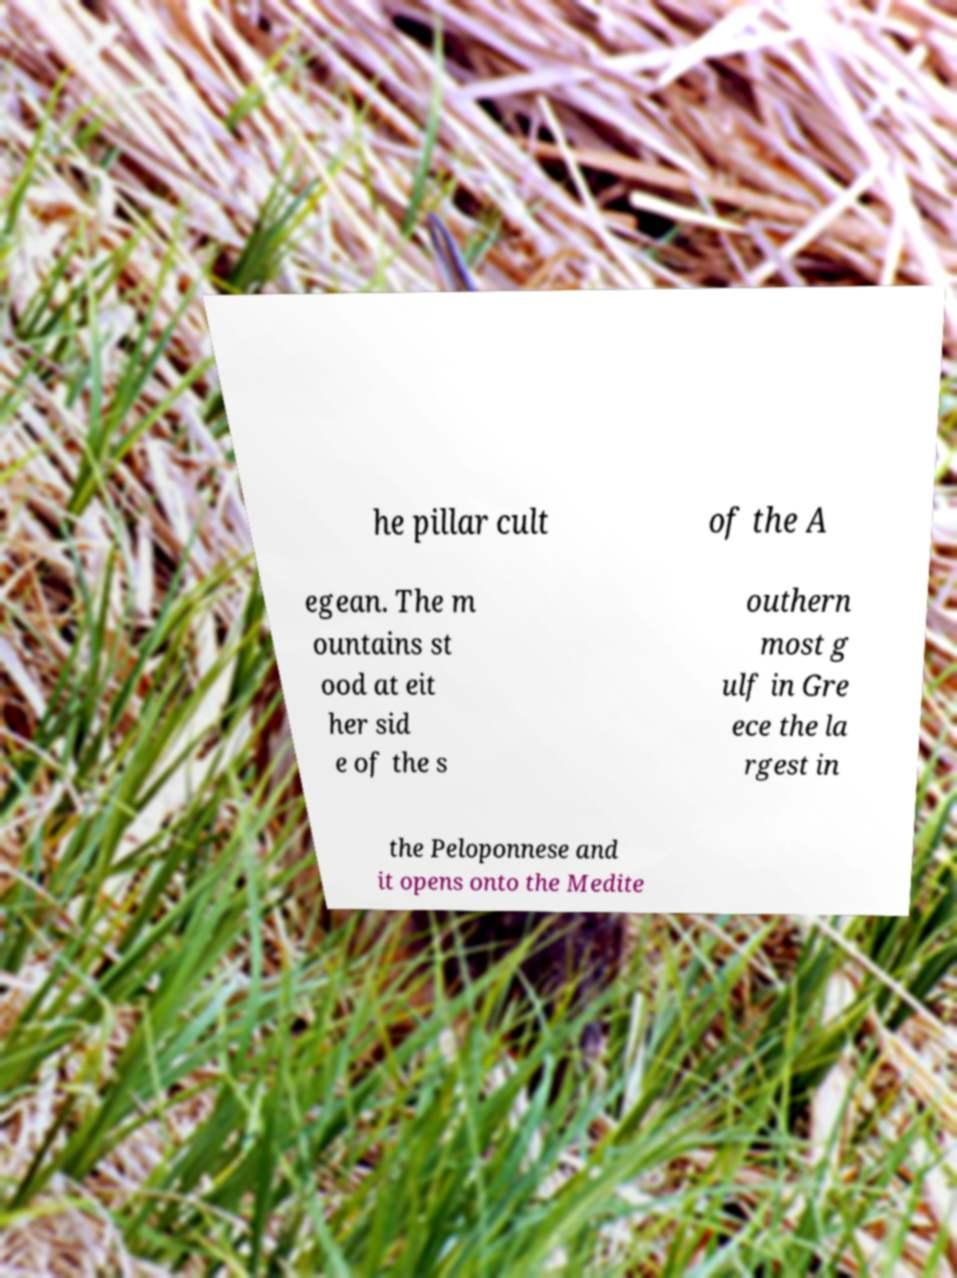Can you accurately transcribe the text from the provided image for me? he pillar cult of the A egean. The m ountains st ood at eit her sid e of the s outhern most g ulf in Gre ece the la rgest in the Peloponnese and it opens onto the Medite 